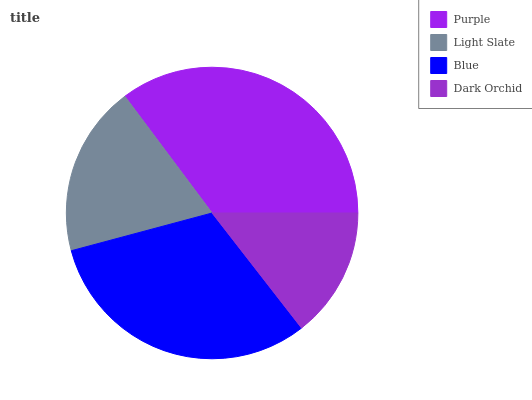Is Dark Orchid the minimum?
Answer yes or no. Yes. Is Purple the maximum?
Answer yes or no. Yes. Is Light Slate the minimum?
Answer yes or no. No. Is Light Slate the maximum?
Answer yes or no. No. Is Purple greater than Light Slate?
Answer yes or no. Yes. Is Light Slate less than Purple?
Answer yes or no. Yes. Is Light Slate greater than Purple?
Answer yes or no. No. Is Purple less than Light Slate?
Answer yes or no. No. Is Blue the high median?
Answer yes or no. Yes. Is Light Slate the low median?
Answer yes or no. Yes. Is Light Slate the high median?
Answer yes or no. No. Is Blue the low median?
Answer yes or no. No. 